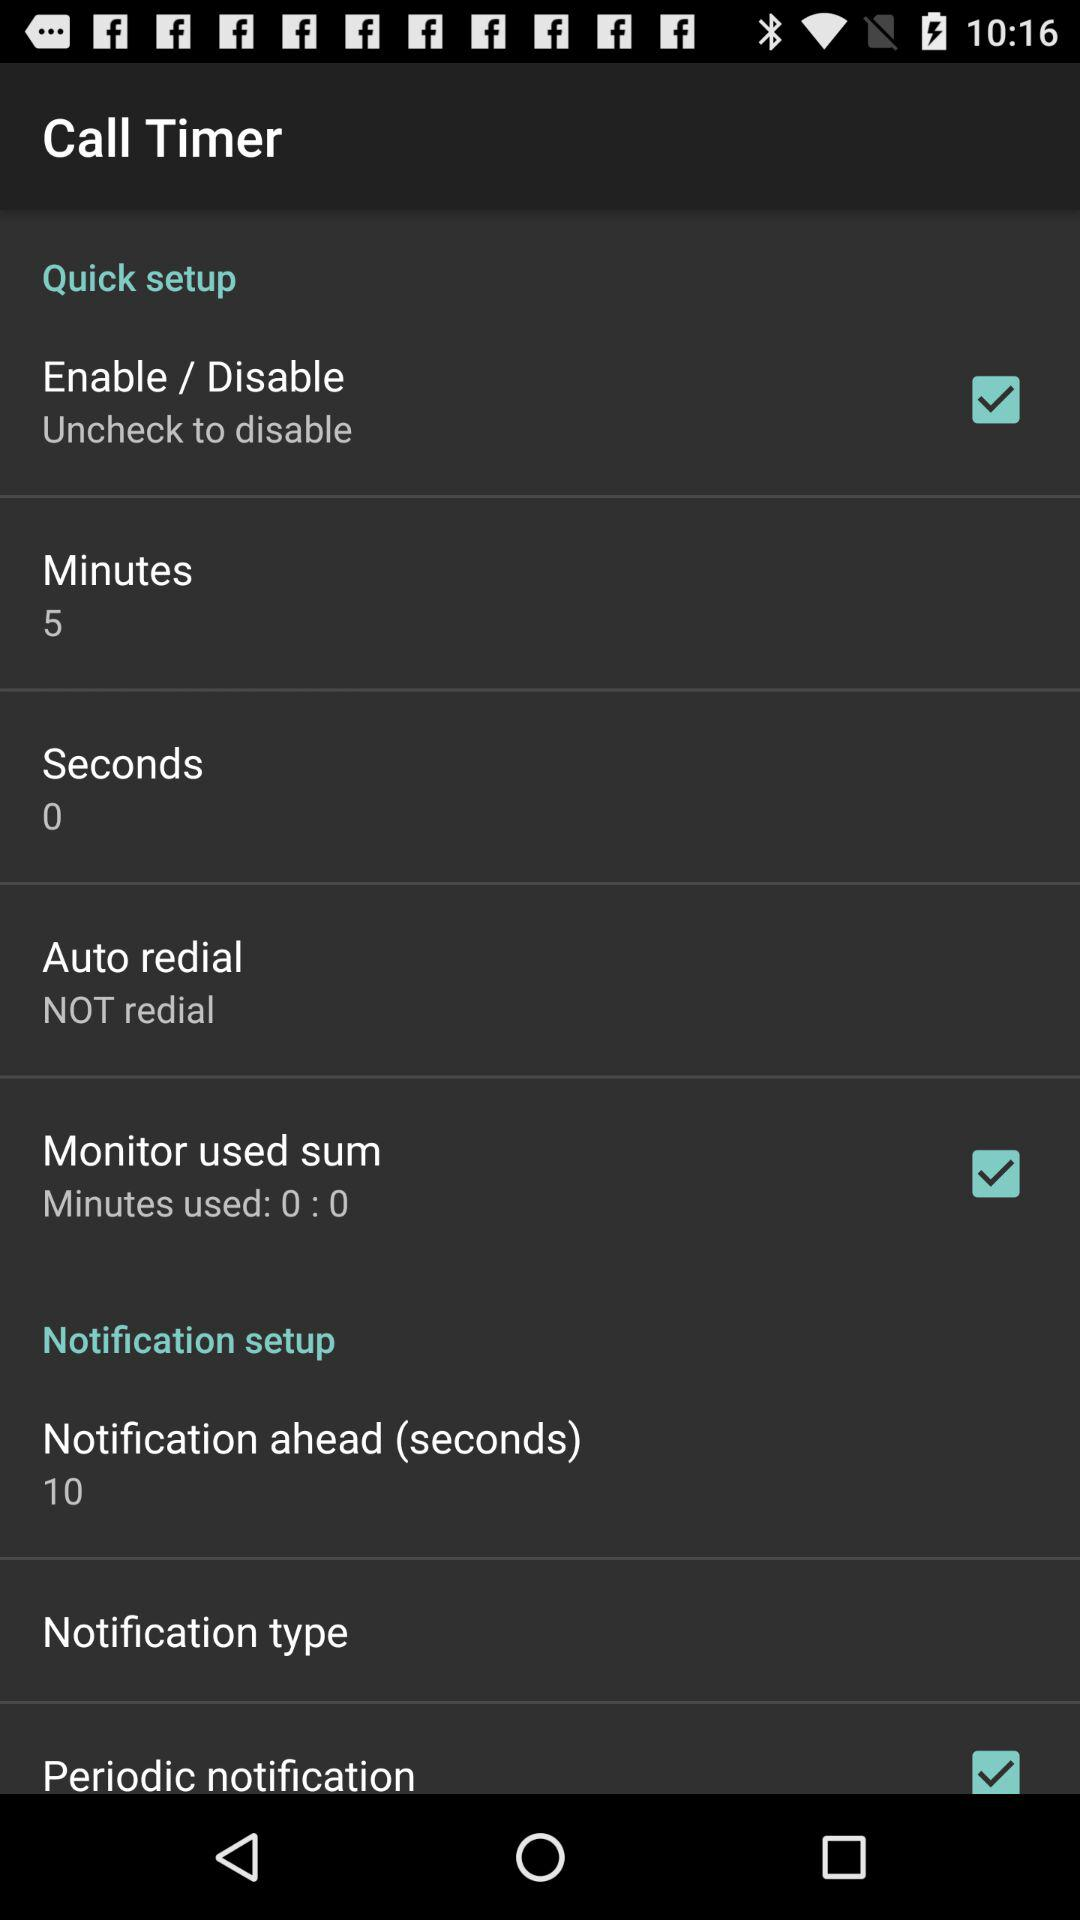What option is selected in the "Auto redial"? The selected option is "Not redial". 